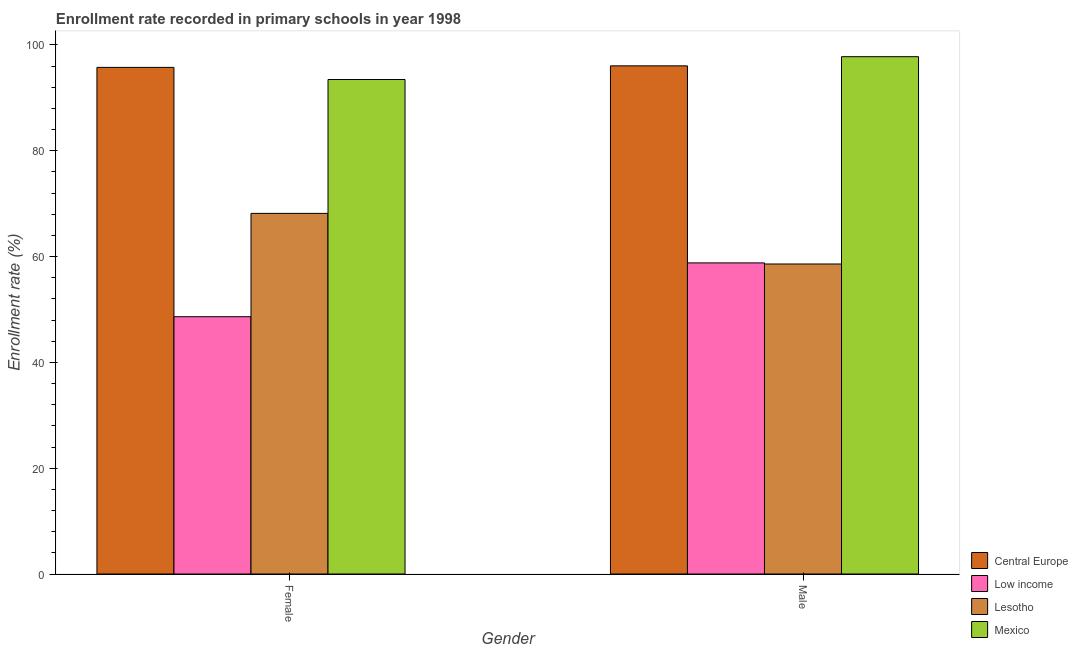How many groups of bars are there?
Make the answer very short. 2. Are the number of bars on each tick of the X-axis equal?
Offer a very short reply. Yes. What is the enrollment rate of male students in Central Europe?
Your answer should be very brief. 96.06. Across all countries, what is the maximum enrollment rate of male students?
Offer a terse response. 97.79. Across all countries, what is the minimum enrollment rate of male students?
Ensure brevity in your answer.  58.6. What is the total enrollment rate of female students in the graph?
Your answer should be very brief. 306.04. What is the difference between the enrollment rate of male students in Mexico and that in Low income?
Keep it short and to the point. 38.98. What is the difference between the enrollment rate of male students in Central Europe and the enrollment rate of female students in Low income?
Give a very brief answer. 47.42. What is the average enrollment rate of male students per country?
Your response must be concise. 77.81. What is the difference between the enrollment rate of male students and enrollment rate of female students in Lesotho?
Offer a terse response. -9.57. What is the ratio of the enrollment rate of female students in Mexico to that in Lesotho?
Provide a succinct answer. 1.37. Is the enrollment rate of male students in Mexico less than that in Low income?
Keep it short and to the point. No. What does the 3rd bar from the left in Female represents?
Your answer should be compact. Lesotho. What does the 4th bar from the right in Male represents?
Give a very brief answer. Central Europe. How many bars are there?
Offer a terse response. 8. Are all the bars in the graph horizontal?
Give a very brief answer. No. How many countries are there in the graph?
Provide a short and direct response. 4. What is the difference between two consecutive major ticks on the Y-axis?
Give a very brief answer. 20. Does the graph contain any zero values?
Ensure brevity in your answer.  No. What is the title of the graph?
Keep it short and to the point. Enrollment rate recorded in primary schools in year 1998. Does "Slovenia" appear as one of the legend labels in the graph?
Your response must be concise. No. What is the label or title of the X-axis?
Provide a succinct answer. Gender. What is the label or title of the Y-axis?
Make the answer very short. Enrollment rate (%). What is the Enrollment rate (%) in Central Europe in Female?
Your response must be concise. 95.77. What is the Enrollment rate (%) of Low income in Female?
Your answer should be very brief. 48.64. What is the Enrollment rate (%) in Lesotho in Female?
Give a very brief answer. 68.17. What is the Enrollment rate (%) in Mexico in Female?
Provide a succinct answer. 93.48. What is the Enrollment rate (%) in Central Europe in Male?
Your response must be concise. 96.06. What is the Enrollment rate (%) of Low income in Male?
Your answer should be very brief. 58.81. What is the Enrollment rate (%) in Lesotho in Male?
Your response must be concise. 58.6. What is the Enrollment rate (%) in Mexico in Male?
Provide a succinct answer. 97.79. Across all Gender, what is the maximum Enrollment rate (%) of Central Europe?
Offer a terse response. 96.06. Across all Gender, what is the maximum Enrollment rate (%) of Low income?
Provide a short and direct response. 58.81. Across all Gender, what is the maximum Enrollment rate (%) of Lesotho?
Provide a succinct answer. 68.17. Across all Gender, what is the maximum Enrollment rate (%) of Mexico?
Provide a succinct answer. 97.79. Across all Gender, what is the minimum Enrollment rate (%) of Central Europe?
Your answer should be very brief. 95.77. Across all Gender, what is the minimum Enrollment rate (%) of Low income?
Ensure brevity in your answer.  48.64. Across all Gender, what is the minimum Enrollment rate (%) of Lesotho?
Offer a terse response. 58.6. Across all Gender, what is the minimum Enrollment rate (%) in Mexico?
Keep it short and to the point. 93.48. What is the total Enrollment rate (%) of Central Europe in the graph?
Offer a very short reply. 191.82. What is the total Enrollment rate (%) in Low income in the graph?
Your response must be concise. 107.44. What is the total Enrollment rate (%) of Lesotho in the graph?
Make the answer very short. 126.77. What is the total Enrollment rate (%) in Mexico in the graph?
Offer a terse response. 191.26. What is the difference between the Enrollment rate (%) of Central Europe in Female and that in Male?
Your answer should be compact. -0.29. What is the difference between the Enrollment rate (%) of Low income in Female and that in Male?
Offer a very short reply. -10.17. What is the difference between the Enrollment rate (%) in Lesotho in Female and that in Male?
Offer a very short reply. 9.57. What is the difference between the Enrollment rate (%) of Mexico in Female and that in Male?
Keep it short and to the point. -4.31. What is the difference between the Enrollment rate (%) of Central Europe in Female and the Enrollment rate (%) of Low income in Male?
Offer a very short reply. 36.96. What is the difference between the Enrollment rate (%) in Central Europe in Female and the Enrollment rate (%) in Lesotho in Male?
Your response must be concise. 37.16. What is the difference between the Enrollment rate (%) in Central Europe in Female and the Enrollment rate (%) in Mexico in Male?
Your answer should be very brief. -2.02. What is the difference between the Enrollment rate (%) in Low income in Female and the Enrollment rate (%) in Lesotho in Male?
Provide a short and direct response. -9.96. What is the difference between the Enrollment rate (%) in Low income in Female and the Enrollment rate (%) in Mexico in Male?
Offer a very short reply. -49.15. What is the difference between the Enrollment rate (%) of Lesotho in Female and the Enrollment rate (%) of Mexico in Male?
Your answer should be compact. -29.62. What is the average Enrollment rate (%) in Central Europe per Gender?
Provide a succinct answer. 95.91. What is the average Enrollment rate (%) in Low income per Gender?
Give a very brief answer. 53.72. What is the average Enrollment rate (%) of Lesotho per Gender?
Provide a succinct answer. 63.38. What is the average Enrollment rate (%) of Mexico per Gender?
Your answer should be compact. 95.63. What is the difference between the Enrollment rate (%) in Central Europe and Enrollment rate (%) in Low income in Female?
Ensure brevity in your answer.  47.13. What is the difference between the Enrollment rate (%) of Central Europe and Enrollment rate (%) of Lesotho in Female?
Ensure brevity in your answer.  27.6. What is the difference between the Enrollment rate (%) in Central Europe and Enrollment rate (%) in Mexico in Female?
Your answer should be compact. 2.29. What is the difference between the Enrollment rate (%) of Low income and Enrollment rate (%) of Lesotho in Female?
Your answer should be compact. -19.53. What is the difference between the Enrollment rate (%) in Low income and Enrollment rate (%) in Mexico in Female?
Make the answer very short. -44.84. What is the difference between the Enrollment rate (%) of Lesotho and Enrollment rate (%) of Mexico in Female?
Make the answer very short. -25.31. What is the difference between the Enrollment rate (%) of Central Europe and Enrollment rate (%) of Low income in Male?
Provide a short and direct response. 37.25. What is the difference between the Enrollment rate (%) of Central Europe and Enrollment rate (%) of Lesotho in Male?
Your answer should be very brief. 37.45. What is the difference between the Enrollment rate (%) of Central Europe and Enrollment rate (%) of Mexico in Male?
Your answer should be very brief. -1.73. What is the difference between the Enrollment rate (%) of Low income and Enrollment rate (%) of Lesotho in Male?
Give a very brief answer. 0.21. What is the difference between the Enrollment rate (%) in Low income and Enrollment rate (%) in Mexico in Male?
Keep it short and to the point. -38.98. What is the difference between the Enrollment rate (%) of Lesotho and Enrollment rate (%) of Mexico in Male?
Ensure brevity in your answer.  -39.19. What is the ratio of the Enrollment rate (%) in Low income in Female to that in Male?
Offer a terse response. 0.83. What is the ratio of the Enrollment rate (%) in Lesotho in Female to that in Male?
Provide a succinct answer. 1.16. What is the ratio of the Enrollment rate (%) of Mexico in Female to that in Male?
Provide a short and direct response. 0.96. What is the difference between the highest and the second highest Enrollment rate (%) in Central Europe?
Give a very brief answer. 0.29. What is the difference between the highest and the second highest Enrollment rate (%) of Low income?
Provide a short and direct response. 10.17. What is the difference between the highest and the second highest Enrollment rate (%) in Lesotho?
Offer a terse response. 9.57. What is the difference between the highest and the second highest Enrollment rate (%) in Mexico?
Your response must be concise. 4.31. What is the difference between the highest and the lowest Enrollment rate (%) in Central Europe?
Offer a very short reply. 0.29. What is the difference between the highest and the lowest Enrollment rate (%) of Low income?
Give a very brief answer. 10.17. What is the difference between the highest and the lowest Enrollment rate (%) in Lesotho?
Provide a succinct answer. 9.57. What is the difference between the highest and the lowest Enrollment rate (%) of Mexico?
Make the answer very short. 4.31. 